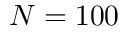Convert formula to latex. <formula><loc_0><loc_0><loc_500><loc_500>N = 1 0 0</formula> 